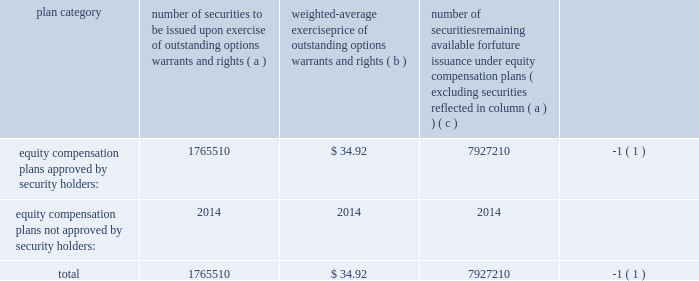Item 11 2014executive compensation we incorporate by reference in this item 11 the information relating to executive and director compensation contained under the headings 201cother information about the board and its committees , 201d 201ccompensation and other benefits 201d and 201creport of the compensation committee 201d from our proxy statement to be delivered in connection with our 2013 annual meeting of shareholders to be held on november 20 , 2013 .
Item 12 2014security ownership of certain beneficial owners and management and related stockholder matters we incorporate by reference in this item 12 the information relating to ownership of our common stock by certain persons contained under the headings 201ccommon stock ownership of management 201d and 201ccommon stock ownership by certain other persons 201d from our proxy statement to be delivered in connection with our 2013 annual meeting of shareholders to be held on november 20 , 2013 .
The table provides certain information as of may 31 , 2013 concerning the shares of the company 2019s common stock that may be issued under existing equity compensation plans .
For more information on these plans , see note 11 to notes to consolidated financial statements .
Plan category number of securities to be issued upon exercise of outstanding options , warrants and rights weighted- average exercise price of outstanding options , warrants and rights number of securities remaining available for future issuance under equity compensation plans ( excluding securities reflected in column ( a ) ) equity compensation plans approved by security holders : 1765510 $ 34.92 7927210 ( 1 ) equity compensation plans not approved by security holders : 2014 2014 2014 .
( 1 ) also includes shares of common stock available for issuance other than upon the exercise of an option , warrant or right under the global payments inc .
2000 long-term incentive plan , as amended and restated , the global payments inc .
Amended and restated 2005 incentive plan , amended and restated 2000 non- employee director stock option plan , global payments employee stock purchase plan and the global payments inc .
2011 incentive plan .
Item 13 2014certain relationships and related transactions , and director independence we incorporate by reference in this item 13 the information regarding certain relationships and related transactions between us and some of our affiliates and the independence of our board of directors contained under the headings 201ccertain relationships and related transactions 201d and 201cother information about the board and its committees 201d from our proxy statement to be delivered in connection with our 2013 annual meeting of shareholders to be held on november 20 , 2013 .
Item 14 2014principal accounting fees and services we incorporate by reference in this item 14 the information regarding principal accounting fees and services contained under the section ratification of the reappointment of auditors from our proxy statement to be delivered in connection with our 2013 annual meeting of shareholders to be held on november 20 , 2013. .
What is the estimated value of the available securities for future issuance , ( in millions ) ? 
Computations: ((7927210 * 34.92) / 1000000)
Answer: 276.81817. 